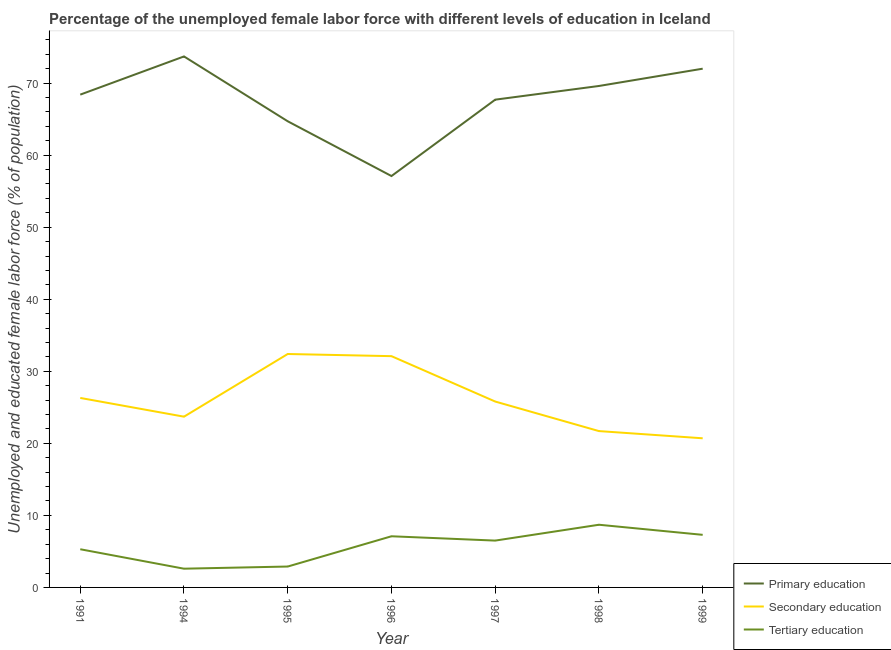How many different coloured lines are there?
Provide a succinct answer. 3. What is the percentage of female labor force who received tertiary education in 1991?
Ensure brevity in your answer.  5.3. Across all years, what is the maximum percentage of female labor force who received tertiary education?
Your response must be concise. 8.7. Across all years, what is the minimum percentage of female labor force who received primary education?
Provide a succinct answer. 57.1. In which year was the percentage of female labor force who received primary education minimum?
Provide a succinct answer. 1996. What is the total percentage of female labor force who received primary education in the graph?
Provide a short and direct response. 473.2. What is the difference between the percentage of female labor force who received tertiary education in 1997 and that in 1999?
Make the answer very short. -0.8. What is the difference between the percentage of female labor force who received tertiary education in 1994 and the percentage of female labor force who received secondary education in 1998?
Provide a short and direct response. -19.1. What is the average percentage of female labor force who received secondary education per year?
Your answer should be very brief. 26.1. In the year 1994, what is the difference between the percentage of female labor force who received tertiary education and percentage of female labor force who received secondary education?
Your answer should be compact. -21.1. In how many years, is the percentage of female labor force who received tertiary education greater than 4 %?
Provide a short and direct response. 5. What is the ratio of the percentage of female labor force who received secondary education in 1997 to that in 1998?
Provide a short and direct response. 1.19. Is the percentage of female labor force who received secondary education in 1996 less than that in 1997?
Provide a succinct answer. No. Is the difference between the percentage of female labor force who received primary education in 1996 and 1997 greater than the difference between the percentage of female labor force who received secondary education in 1996 and 1997?
Make the answer very short. No. What is the difference between the highest and the second highest percentage of female labor force who received tertiary education?
Offer a terse response. 1.4. What is the difference between the highest and the lowest percentage of female labor force who received tertiary education?
Offer a very short reply. 6.1. Is the percentage of female labor force who received secondary education strictly greater than the percentage of female labor force who received primary education over the years?
Provide a short and direct response. No. What is the difference between two consecutive major ticks on the Y-axis?
Your response must be concise. 10. Does the graph contain any zero values?
Provide a short and direct response. No. Does the graph contain grids?
Keep it short and to the point. No. How are the legend labels stacked?
Make the answer very short. Vertical. What is the title of the graph?
Offer a terse response. Percentage of the unemployed female labor force with different levels of education in Iceland. Does "Food" appear as one of the legend labels in the graph?
Your response must be concise. No. What is the label or title of the Y-axis?
Keep it short and to the point. Unemployed and educated female labor force (% of population). What is the Unemployed and educated female labor force (% of population) in Primary education in 1991?
Your answer should be compact. 68.4. What is the Unemployed and educated female labor force (% of population) of Secondary education in 1991?
Your answer should be very brief. 26.3. What is the Unemployed and educated female labor force (% of population) in Tertiary education in 1991?
Your answer should be compact. 5.3. What is the Unemployed and educated female labor force (% of population) in Primary education in 1994?
Your answer should be very brief. 73.7. What is the Unemployed and educated female labor force (% of population) in Secondary education in 1994?
Offer a very short reply. 23.7. What is the Unemployed and educated female labor force (% of population) of Tertiary education in 1994?
Offer a terse response. 2.6. What is the Unemployed and educated female labor force (% of population) of Primary education in 1995?
Your answer should be very brief. 64.7. What is the Unemployed and educated female labor force (% of population) of Secondary education in 1995?
Ensure brevity in your answer.  32.4. What is the Unemployed and educated female labor force (% of population) in Tertiary education in 1995?
Provide a succinct answer. 2.9. What is the Unemployed and educated female labor force (% of population) of Primary education in 1996?
Your answer should be very brief. 57.1. What is the Unemployed and educated female labor force (% of population) in Secondary education in 1996?
Your response must be concise. 32.1. What is the Unemployed and educated female labor force (% of population) of Tertiary education in 1996?
Your answer should be compact. 7.1. What is the Unemployed and educated female labor force (% of population) in Primary education in 1997?
Make the answer very short. 67.7. What is the Unemployed and educated female labor force (% of population) of Secondary education in 1997?
Give a very brief answer. 25.8. What is the Unemployed and educated female labor force (% of population) of Primary education in 1998?
Your answer should be compact. 69.6. What is the Unemployed and educated female labor force (% of population) in Secondary education in 1998?
Give a very brief answer. 21.7. What is the Unemployed and educated female labor force (% of population) in Tertiary education in 1998?
Provide a short and direct response. 8.7. What is the Unemployed and educated female labor force (% of population) of Primary education in 1999?
Your answer should be compact. 72. What is the Unemployed and educated female labor force (% of population) in Secondary education in 1999?
Keep it short and to the point. 20.7. What is the Unemployed and educated female labor force (% of population) in Tertiary education in 1999?
Your response must be concise. 7.3. Across all years, what is the maximum Unemployed and educated female labor force (% of population) in Primary education?
Offer a terse response. 73.7. Across all years, what is the maximum Unemployed and educated female labor force (% of population) of Secondary education?
Give a very brief answer. 32.4. Across all years, what is the maximum Unemployed and educated female labor force (% of population) in Tertiary education?
Provide a short and direct response. 8.7. Across all years, what is the minimum Unemployed and educated female labor force (% of population) in Primary education?
Your answer should be very brief. 57.1. Across all years, what is the minimum Unemployed and educated female labor force (% of population) in Secondary education?
Your answer should be very brief. 20.7. Across all years, what is the minimum Unemployed and educated female labor force (% of population) in Tertiary education?
Provide a succinct answer. 2.6. What is the total Unemployed and educated female labor force (% of population) of Primary education in the graph?
Offer a very short reply. 473.2. What is the total Unemployed and educated female labor force (% of population) of Secondary education in the graph?
Provide a short and direct response. 182.7. What is the total Unemployed and educated female labor force (% of population) of Tertiary education in the graph?
Keep it short and to the point. 40.4. What is the difference between the Unemployed and educated female labor force (% of population) of Secondary education in 1991 and that in 1994?
Provide a succinct answer. 2.6. What is the difference between the Unemployed and educated female labor force (% of population) in Tertiary education in 1991 and that in 1994?
Ensure brevity in your answer.  2.7. What is the difference between the Unemployed and educated female labor force (% of population) in Secondary education in 1991 and that in 1995?
Give a very brief answer. -6.1. What is the difference between the Unemployed and educated female labor force (% of population) in Secondary education in 1991 and that in 1996?
Give a very brief answer. -5.8. What is the difference between the Unemployed and educated female labor force (% of population) of Tertiary education in 1991 and that in 1996?
Offer a terse response. -1.8. What is the difference between the Unemployed and educated female labor force (% of population) of Secondary education in 1991 and that in 1997?
Give a very brief answer. 0.5. What is the difference between the Unemployed and educated female labor force (% of population) of Primary education in 1991 and that in 1998?
Provide a short and direct response. -1.2. What is the difference between the Unemployed and educated female labor force (% of population) in Secondary education in 1991 and that in 1998?
Keep it short and to the point. 4.6. What is the difference between the Unemployed and educated female labor force (% of population) of Primary education in 1991 and that in 1999?
Your answer should be very brief. -3.6. What is the difference between the Unemployed and educated female labor force (% of population) of Secondary education in 1991 and that in 1999?
Your answer should be compact. 5.6. What is the difference between the Unemployed and educated female labor force (% of population) in Primary education in 1994 and that in 1995?
Offer a very short reply. 9. What is the difference between the Unemployed and educated female labor force (% of population) of Tertiary education in 1994 and that in 1995?
Provide a succinct answer. -0.3. What is the difference between the Unemployed and educated female labor force (% of population) of Primary education in 1994 and that in 1997?
Provide a short and direct response. 6. What is the difference between the Unemployed and educated female labor force (% of population) in Secondary education in 1994 and that in 1997?
Your answer should be compact. -2.1. What is the difference between the Unemployed and educated female labor force (% of population) of Tertiary education in 1994 and that in 1997?
Your response must be concise. -3.9. What is the difference between the Unemployed and educated female labor force (% of population) of Tertiary education in 1994 and that in 1998?
Offer a very short reply. -6.1. What is the difference between the Unemployed and educated female labor force (% of population) of Secondary education in 1994 and that in 1999?
Provide a succinct answer. 3. What is the difference between the Unemployed and educated female labor force (% of population) in Tertiary education in 1994 and that in 1999?
Provide a short and direct response. -4.7. What is the difference between the Unemployed and educated female labor force (% of population) of Primary education in 1995 and that in 1996?
Make the answer very short. 7.6. What is the difference between the Unemployed and educated female labor force (% of population) of Secondary education in 1995 and that in 1996?
Your answer should be compact. 0.3. What is the difference between the Unemployed and educated female labor force (% of population) of Primary education in 1995 and that in 1997?
Your response must be concise. -3. What is the difference between the Unemployed and educated female labor force (% of population) in Secondary education in 1995 and that in 1997?
Ensure brevity in your answer.  6.6. What is the difference between the Unemployed and educated female labor force (% of population) of Tertiary education in 1995 and that in 1997?
Ensure brevity in your answer.  -3.6. What is the difference between the Unemployed and educated female labor force (% of population) of Tertiary education in 1995 and that in 1998?
Give a very brief answer. -5.8. What is the difference between the Unemployed and educated female labor force (% of population) of Primary education in 1995 and that in 1999?
Offer a very short reply. -7.3. What is the difference between the Unemployed and educated female labor force (% of population) of Tertiary education in 1996 and that in 1998?
Ensure brevity in your answer.  -1.6. What is the difference between the Unemployed and educated female labor force (% of population) in Primary education in 1996 and that in 1999?
Provide a succinct answer. -14.9. What is the difference between the Unemployed and educated female labor force (% of population) in Secondary education in 1996 and that in 1999?
Provide a succinct answer. 11.4. What is the difference between the Unemployed and educated female labor force (% of population) in Tertiary education in 1996 and that in 1999?
Make the answer very short. -0.2. What is the difference between the Unemployed and educated female labor force (% of population) in Tertiary education in 1997 and that in 1999?
Make the answer very short. -0.8. What is the difference between the Unemployed and educated female labor force (% of population) in Primary education in 1998 and that in 1999?
Make the answer very short. -2.4. What is the difference between the Unemployed and educated female labor force (% of population) in Tertiary education in 1998 and that in 1999?
Provide a short and direct response. 1.4. What is the difference between the Unemployed and educated female labor force (% of population) of Primary education in 1991 and the Unemployed and educated female labor force (% of population) of Secondary education in 1994?
Your response must be concise. 44.7. What is the difference between the Unemployed and educated female labor force (% of population) of Primary education in 1991 and the Unemployed and educated female labor force (% of population) of Tertiary education in 1994?
Make the answer very short. 65.8. What is the difference between the Unemployed and educated female labor force (% of population) of Secondary education in 1991 and the Unemployed and educated female labor force (% of population) of Tertiary education in 1994?
Keep it short and to the point. 23.7. What is the difference between the Unemployed and educated female labor force (% of population) of Primary education in 1991 and the Unemployed and educated female labor force (% of population) of Secondary education in 1995?
Offer a very short reply. 36. What is the difference between the Unemployed and educated female labor force (% of population) of Primary education in 1991 and the Unemployed and educated female labor force (% of population) of Tertiary education in 1995?
Keep it short and to the point. 65.5. What is the difference between the Unemployed and educated female labor force (% of population) in Secondary education in 1991 and the Unemployed and educated female labor force (% of population) in Tertiary education in 1995?
Your answer should be compact. 23.4. What is the difference between the Unemployed and educated female labor force (% of population) of Primary education in 1991 and the Unemployed and educated female labor force (% of population) of Secondary education in 1996?
Make the answer very short. 36.3. What is the difference between the Unemployed and educated female labor force (% of population) of Primary education in 1991 and the Unemployed and educated female labor force (% of population) of Tertiary education in 1996?
Your answer should be compact. 61.3. What is the difference between the Unemployed and educated female labor force (% of population) in Secondary education in 1991 and the Unemployed and educated female labor force (% of population) in Tertiary education in 1996?
Your response must be concise. 19.2. What is the difference between the Unemployed and educated female labor force (% of population) in Primary education in 1991 and the Unemployed and educated female labor force (% of population) in Secondary education in 1997?
Provide a short and direct response. 42.6. What is the difference between the Unemployed and educated female labor force (% of population) of Primary education in 1991 and the Unemployed and educated female labor force (% of population) of Tertiary education in 1997?
Offer a very short reply. 61.9. What is the difference between the Unemployed and educated female labor force (% of population) of Secondary education in 1991 and the Unemployed and educated female labor force (% of population) of Tertiary education in 1997?
Offer a very short reply. 19.8. What is the difference between the Unemployed and educated female labor force (% of population) in Primary education in 1991 and the Unemployed and educated female labor force (% of population) in Secondary education in 1998?
Your response must be concise. 46.7. What is the difference between the Unemployed and educated female labor force (% of population) in Primary education in 1991 and the Unemployed and educated female labor force (% of population) in Tertiary education in 1998?
Provide a short and direct response. 59.7. What is the difference between the Unemployed and educated female labor force (% of population) in Secondary education in 1991 and the Unemployed and educated female labor force (% of population) in Tertiary education in 1998?
Offer a terse response. 17.6. What is the difference between the Unemployed and educated female labor force (% of population) in Primary education in 1991 and the Unemployed and educated female labor force (% of population) in Secondary education in 1999?
Your answer should be very brief. 47.7. What is the difference between the Unemployed and educated female labor force (% of population) of Primary education in 1991 and the Unemployed and educated female labor force (% of population) of Tertiary education in 1999?
Your response must be concise. 61.1. What is the difference between the Unemployed and educated female labor force (% of population) of Secondary education in 1991 and the Unemployed and educated female labor force (% of population) of Tertiary education in 1999?
Ensure brevity in your answer.  19. What is the difference between the Unemployed and educated female labor force (% of population) in Primary education in 1994 and the Unemployed and educated female labor force (% of population) in Secondary education in 1995?
Make the answer very short. 41.3. What is the difference between the Unemployed and educated female labor force (% of population) in Primary education in 1994 and the Unemployed and educated female labor force (% of population) in Tertiary education in 1995?
Offer a terse response. 70.8. What is the difference between the Unemployed and educated female labor force (% of population) in Secondary education in 1994 and the Unemployed and educated female labor force (% of population) in Tertiary education in 1995?
Keep it short and to the point. 20.8. What is the difference between the Unemployed and educated female labor force (% of population) in Primary education in 1994 and the Unemployed and educated female labor force (% of population) in Secondary education in 1996?
Provide a short and direct response. 41.6. What is the difference between the Unemployed and educated female labor force (% of population) of Primary education in 1994 and the Unemployed and educated female labor force (% of population) of Tertiary education in 1996?
Offer a terse response. 66.6. What is the difference between the Unemployed and educated female labor force (% of population) in Secondary education in 1994 and the Unemployed and educated female labor force (% of population) in Tertiary education in 1996?
Your answer should be very brief. 16.6. What is the difference between the Unemployed and educated female labor force (% of population) in Primary education in 1994 and the Unemployed and educated female labor force (% of population) in Secondary education in 1997?
Provide a short and direct response. 47.9. What is the difference between the Unemployed and educated female labor force (% of population) of Primary education in 1994 and the Unemployed and educated female labor force (% of population) of Tertiary education in 1997?
Your answer should be compact. 67.2. What is the difference between the Unemployed and educated female labor force (% of population) of Primary education in 1994 and the Unemployed and educated female labor force (% of population) of Tertiary education in 1998?
Offer a terse response. 65. What is the difference between the Unemployed and educated female labor force (% of population) of Primary education in 1994 and the Unemployed and educated female labor force (% of population) of Secondary education in 1999?
Your answer should be very brief. 53. What is the difference between the Unemployed and educated female labor force (% of population) of Primary education in 1994 and the Unemployed and educated female labor force (% of population) of Tertiary education in 1999?
Offer a very short reply. 66.4. What is the difference between the Unemployed and educated female labor force (% of population) in Primary education in 1995 and the Unemployed and educated female labor force (% of population) in Secondary education in 1996?
Make the answer very short. 32.6. What is the difference between the Unemployed and educated female labor force (% of population) of Primary education in 1995 and the Unemployed and educated female labor force (% of population) of Tertiary education in 1996?
Offer a terse response. 57.6. What is the difference between the Unemployed and educated female labor force (% of population) in Secondary education in 1995 and the Unemployed and educated female labor force (% of population) in Tertiary education in 1996?
Your answer should be very brief. 25.3. What is the difference between the Unemployed and educated female labor force (% of population) in Primary education in 1995 and the Unemployed and educated female labor force (% of population) in Secondary education in 1997?
Keep it short and to the point. 38.9. What is the difference between the Unemployed and educated female labor force (% of population) of Primary education in 1995 and the Unemployed and educated female labor force (% of population) of Tertiary education in 1997?
Offer a very short reply. 58.2. What is the difference between the Unemployed and educated female labor force (% of population) in Secondary education in 1995 and the Unemployed and educated female labor force (% of population) in Tertiary education in 1997?
Offer a very short reply. 25.9. What is the difference between the Unemployed and educated female labor force (% of population) in Primary education in 1995 and the Unemployed and educated female labor force (% of population) in Tertiary education in 1998?
Your response must be concise. 56. What is the difference between the Unemployed and educated female labor force (% of population) in Secondary education in 1995 and the Unemployed and educated female labor force (% of population) in Tertiary education in 1998?
Your response must be concise. 23.7. What is the difference between the Unemployed and educated female labor force (% of population) of Primary education in 1995 and the Unemployed and educated female labor force (% of population) of Tertiary education in 1999?
Your answer should be very brief. 57.4. What is the difference between the Unemployed and educated female labor force (% of population) of Secondary education in 1995 and the Unemployed and educated female labor force (% of population) of Tertiary education in 1999?
Ensure brevity in your answer.  25.1. What is the difference between the Unemployed and educated female labor force (% of population) in Primary education in 1996 and the Unemployed and educated female labor force (% of population) in Secondary education in 1997?
Your answer should be very brief. 31.3. What is the difference between the Unemployed and educated female labor force (% of population) in Primary education in 1996 and the Unemployed and educated female labor force (% of population) in Tertiary education in 1997?
Give a very brief answer. 50.6. What is the difference between the Unemployed and educated female labor force (% of population) of Secondary education in 1996 and the Unemployed and educated female labor force (% of population) of Tertiary education in 1997?
Your response must be concise. 25.6. What is the difference between the Unemployed and educated female labor force (% of population) in Primary education in 1996 and the Unemployed and educated female labor force (% of population) in Secondary education in 1998?
Your answer should be very brief. 35.4. What is the difference between the Unemployed and educated female labor force (% of population) in Primary education in 1996 and the Unemployed and educated female labor force (% of population) in Tertiary education in 1998?
Provide a short and direct response. 48.4. What is the difference between the Unemployed and educated female labor force (% of population) in Secondary education in 1996 and the Unemployed and educated female labor force (% of population) in Tertiary education in 1998?
Provide a short and direct response. 23.4. What is the difference between the Unemployed and educated female labor force (% of population) of Primary education in 1996 and the Unemployed and educated female labor force (% of population) of Secondary education in 1999?
Give a very brief answer. 36.4. What is the difference between the Unemployed and educated female labor force (% of population) of Primary education in 1996 and the Unemployed and educated female labor force (% of population) of Tertiary education in 1999?
Your answer should be compact. 49.8. What is the difference between the Unemployed and educated female labor force (% of population) in Secondary education in 1996 and the Unemployed and educated female labor force (% of population) in Tertiary education in 1999?
Your response must be concise. 24.8. What is the difference between the Unemployed and educated female labor force (% of population) in Primary education in 1997 and the Unemployed and educated female labor force (% of population) in Secondary education in 1998?
Give a very brief answer. 46. What is the difference between the Unemployed and educated female labor force (% of population) of Primary education in 1997 and the Unemployed and educated female labor force (% of population) of Tertiary education in 1998?
Your answer should be very brief. 59. What is the difference between the Unemployed and educated female labor force (% of population) in Secondary education in 1997 and the Unemployed and educated female labor force (% of population) in Tertiary education in 1998?
Your response must be concise. 17.1. What is the difference between the Unemployed and educated female labor force (% of population) of Primary education in 1997 and the Unemployed and educated female labor force (% of population) of Tertiary education in 1999?
Provide a short and direct response. 60.4. What is the difference between the Unemployed and educated female labor force (% of population) in Secondary education in 1997 and the Unemployed and educated female labor force (% of population) in Tertiary education in 1999?
Ensure brevity in your answer.  18.5. What is the difference between the Unemployed and educated female labor force (% of population) in Primary education in 1998 and the Unemployed and educated female labor force (% of population) in Secondary education in 1999?
Your answer should be compact. 48.9. What is the difference between the Unemployed and educated female labor force (% of population) in Primary education in 1998 and the Unemployed and educated female labor force (% of population) in Tertiary education in 1999?
Provide a succinct answer. 62.3. What is the difference between the Unemployed and educated female labor force (% of population) of Secondary education in 1998 and the Unemployed and educated female labor force (% of population) of Tertiary education in 1999?
Give a very brief answer. 14.4. What is the average Unemployed and educated female labor force (% of population) in Primary education per year?
Offer a very short reply. 67.6. What is the average Unemployed and educated female labor force (% of population) of Secondary education per year?
Your response must be concise. 26.1. What is the average Unemployed and educated female labor force (% of population) in Tertiary education per year?
Offer a very short reply. 5.77. In the year 1991, what is the difference between the Unemployed and educated female labor force (% of population) of Primary education and Unemployed and educated female labor force (% of population) of Secondary education?
Your answer should be very brief. 42.1. In the year 1991, what is the difference between the Unemployed and educated female labor force (% of population) in Primary education and Unemployed and educated female labor force (% of population) in Tertiary education?
Keep it short and to the point. 63.1. In the year 1991, what is the difference between the Unemployed and educated female labor force (% of population) in Secondary education and Unemployed and educated female labor force (% of population) in Tertiary education?
Keep it short and to the point. 21. In the year 1994, what is the difference between the Unemployed and educated female labor force (% of population) of Primary education and Unemployed and educated female labor force (% of population) of Secondary education?
Your response must be concise. 50. In the year 1994, what is the difference between the Unemployed and educated female labor force (% of population) of Primary education and Unemployed and educated female labor force (% of population) of Tertiary education?
Provide a short and direct response. 71.1. In the year 1994, what is the difference between the Unemployed and educated female labor force (% of population) in Secondary education and Unemployed and educated female labor force (% of population) in Tertiary education?
Your response must be concise. 21.1. In the year 1995, what is the difference between the Unemployed and educated female labor force (% of population) of Primary education and Unemployed and educated female labor force (% of population) of Secondary education?
Your answer should be compact. 32.3. In the year 1995, what is the difference between the Unemployed and educated female labor force (% of population) of Primary education and Unemployed and educated female labor force (% of population) of Tertiary education?
Your response must be concise. 61.8. In the year 1995, what is the difference between the Unemployed and educated female labor force (% of population) of Secondary education and Unemployed and educated female labor force (% of population) of Tertiary education?
Your answer should be very brief. 29.5. In the year 1996, what is the difference between the Unemployed and educated female labor force (% of population) of Primary education and Unemployed and educated female labor force (% of population) of Secondary education?
Your response must be concise. 25. In the year 1997, what is the difference between the Unemployed and educated female labor force (% of population) in Primary education and Unemployed and educated female labor force (% of population) in Secondary education?
Make the answer very short. 41.9. In the year 1997, what is the difference between the Unemployed and educated female labor force (% of population) in Primary education and Unemployed and educated female labor force (% of population) in Tertiary education?
Keep it short and to the point. 61.2. In the year 1997, what is the difference between the Unemployed and educated female labor force (% of population) in Secondary education and Unemployed and educated female labor force (% of population) in Tertiary education?
Ensure brevity in your answer.  19.3. In the year 1998, what is the difference between the Unemployed and educated female labor force (% of population) of Primary education and Unemployed and educated female labor force (% of population) of Secondary education?
Offer a very short reply. 47.9. In the year 1998, what is the difference between the Unemployed and educated female labor force (% of population) in Primary education and Unemployed and educated female labor force (% of population) in Tertiary education?
Your answer should be compact. 60.9. In the year 1999, what is the difference between the Unemployed and educated female labor force (% of population) in Primary education and Unemployed and educated female labor force (% of population) in Secondary education?
Offer a terse response. 51.3. In the year 1999, what is the difference between the Unemployed and educated female labor force (% of population) of Primary education and Unemployed and educated female labor force (% of population) of Tertiary education?
Your answer should be compact. 64.7. In the year 1999, what is the difference between the Unemployed and educated female labor force (% of population) of Secondary education and Unemployed and educated female labor force (% of population) of Tertiary education?
Provide a short and direct response. 13.4. What is the ratio of the Unemployed and educated female labor force (% of population) of Primary education in 1991 to that in 1994?
Offer a very short reply. 0.93. What is the ratio of the Unemployed and educated female labor force (% of population) of Secondary education in 1991 to that in 1994?
Ensure brevity in your answer.  1.11. What is the ratio of the Unemployed and educated female labor force (% of population) of Tertiary education in 1991 to that in 1994?
Your answer should be compact. 2.04. What is the ratio of the Unemployed and educated female labor force (% of population) in Primary education in 1991 to that in 1995?
Provide a short and direct response. 1.06. What is the ratio of the Unemployed and educated female labor force (% of population) of Secondary education in 1991 to that in 1995?
Provide a short and direct response. 0.81. What is the ratio of the Unemployed and educated female labor force (% of population) in Tertiary education in 1991 to that in 1995?
Your response must be concise. 1.83. What is the ratio of the Unemployed and educated female labor force (% of population) in Primary education in 1991 to that in 1996?
Offer a terse response. 1.2. What is the ratio of the Unemployed and educated female labor force (% of population) of Secondary education in 1991 to that in 1996?
Your response must be concise. 0.82. What is the ratio of the Unemployed and educated female labor force (% of population) of Tertiary education in 1991 to that in 1996?
Your answer should be compact. 0.75. What is the ratio of the Unemployed and educated female labor force (% of population) in Primary education in 1991 to that in 1997?
Ensure brevity in your answer.  1.01. What is the ratio of the Unemployed and educated female labor force (% of population) in Secondary education in 1991 to that in 1997?
Keep it short and to the point. 1.02. What is the ratio of the Unemployed and educated female labor force (% of population) in Tertiary education in 1991 to that in 1997?
Make the answer very short. 0.82. What is the ratio of the Unemployed and educated female labor force (% of population) of Primary education in 1991 to that in 1998?
Keep it short and to the point. 0.98. What is the ratio of the Unemployed and educated female labor force (% of population) of Secondary education in 1991 to that in 1998?
Make the answer very short. 1.21. What is the ratio of the Unemployed and educated female labor force (% of population) in Tertiary education in 1991 to that in 1998?
Give a very brief answer. 0.61. What is the ratio of the Unemployed and educated female labor force (% of population) in Primary education in 1991 to that in 1999?
Make the answer very short. 0.95. What is the ratio of the Unemployed and educated female labor force (% of population) in Secondary education in 1991 to that in 1999?
Provide a short and direct response. 1.27. What is the ratio of the Unemployed and educated female labor force (% of population) in Tertiary education in 1991 to that in 1999?
Keep it short and to the point. 0.73. What is the ratio of the Unemployed and educated female labor force (% of population) in Primary education in 1994 to that in 1995?
Provide a succinct answer. 1.14. What is the ratio of the Unemployed and educated female labor force (% of population) in Secondary education in 1994 to that in 1995?
Your answer should be compact. 0.73. What is the ratio of the Unemployed and educated female labor force (% of population) in Tertiary education in 1994 to that in 1995?
Offer a terse response. 0.9. What is the ratio of the Unemployed and educated female labor force (% of population) of Primary education in 1994 to that in 1996?
Your answer should be compact. 1.29. What is the ratio of the Unemployed and educated female labor force (% of population) of Secondary education in 1994 to that in 1996?
Your response must be concise. 0.74. What is the ratio of the Unemployed and educated female labor force (% of population) in Tertiary education in 1994 to that in 1996?
Your answer should be very brief. 0.37. What is the ratio of the Unemployed and educated female labor force (% of population) of Primary education in 1994 to that in 1997?
Give a very brief answer. 1.09. What is the ratio of the Unemployed and educated female labor force (% of population) in Secondary education in 1994 to that in 1997?
Your answer should be very brief. 0.92. What is the ratio of the Unemployed and educated female labor force (% of population) of Primary education in 1994 to that in 1998?
Ensure brevity in your answer.  1.06. What is the ratio of the Unemployed and educated female labor force (% of population) in Secondary education in 1994 to that in 1998?
Your response must be concise. 1.09. What is the ratio of the Unemployed and educated female labor force (% of population) in Tertiary education in 1994 to that in 1998?
Provide a short and direct response. 0.3. What is the ratio of the Unemployed and educated female labor force (% of population) of Primary education in 1994 to that in 1999?
Your response must be concise. 1.02. What is the ratio of the Unemployed and educated female labor force (% of population) of Secondary education in 1994 to that in 1999?
Keep it short and to the point. 1.14. What is the ratio of the Unemployed and educated female labor force (% of population) in Tertiary education in 1994 to that in 1999?
Offer a terse response. 0.36. What is the ratio of the Unemployed and educated female labor force (% of population) in Primary education in 1995 to that in 1996?
Ensure brevity in your answer.  1.13. What is the ratio of the Unemployed and educated female labor force (% of population) of Secondary education in 1995 to that in 1996?
Offer a very short reply. 1.01. What is the ratio of the Unemployed and educated female labor force (% of population) of Tertiary education in 1995 to that in 1996?
Offer a terse response. 0.41. What is the ratio of the Unemployed and educated female labor force (% of population) of Primary education in 1995 to that in 1997?
Make the answer very short. 0.96. What is the ratio of the Unemployed and educated female labor force (% of population) in Secondary education in 1995 to that in 1997?
Give a very brief answer. 1.26. What is the ratio of the Unemployed and educated female labor force (% of population) in Tertiary education in 1995 to that in 1997?
Provide a short and direct response. 0.45. What is the ratio of the Unemployed and educated female labor force (% of population) in Primary education in 1995 to that in 1998?
Provide a short and direct response. 0.93. What is the ratio of the Unemployed and educated female labor force (% of population) of Secondary education in 1995 to that in 1998?
Give a very brief answer. 1.49. What is the ratio of the Unemployed and educated female labor force (% of population) in Tertiary education in 1995 to that in 1998?
Ensure brevity in your answer.  0.33. What is the ratio of the Unemployed and educated female labor force (% of population) in Primary education in 1995 to that in 1999?
Your response must be concise. 0.9. What is the ratio of the Unemployed and educated female labor force (% of population) of Secondary education in 1995 to that in 1999?
Offer a terse response. 1.57. What is the ratio of the Unemployed and educated female labor force (% of population) in Tertiary education in 1995 to that in 1999?
Provide a succinct answer. 0.4. What is the ratio of the Unemployed and educated female labor force (% of population) in Primary education in 1996 to that in 1997?
Ensure brevity in your answer.  0.84. What is the ratio of the Unemployed and educated female labor force (% of population) in Secondary education in 1996 to that in 1997?
Your answer should be compact. 1.24. What is the ratio of the Unemployed and educated female labor force (% of population) of Tertiary education in 1996 to that in 1997?
Give a very brief answer. 1.09. What is the ratio of the Unemployed and educated female labor force (% of population) of Primary education in 1996 to that in 1998?
Your response must be concise. 0.82. What is the ratio of the Unemployed and educated female labor force (% of population) of Secondary education in 1996 to that in 1998?
Make the answer very short. 1.48. What is the ratio of the Unemployed and educated female labor force (% of population) of Tertiary education in 1996 to that in 1998?
Your response must be concise. 0.82. What is the ratio of the Unemployed and educated female labor force (% of population) of Primary education in 1996 to that in 1999?
Ensure brevity in your answer.  0.79. What is the ratio of the Unemployed and educated female labor force (% of population) in Secondary education in 1996 to that in 1999?
Offer a very short reply. 1.55. What is the ratio of the Unemployed and educated female labor force (% of population) of Tertiary education in 1996 to that in 1999?
Your answer should be very brief. 0.97. What is the ratio of the Unemployed and educated female labor force (% of population) in Primary education in 1997 to that in 1998?
Your answer should be very brief. 0.97. What is the ratio of the Unemployed and educated female labor force (% of population) of Secondary education in 1997 to that in 1998?
Give a very brief answer. 1.19. What is the ratio of the Unemployed and educated female labor force (% of population) in Tertiary education in 1997 to that in 1998?
Your answer should be compact. 0.75. What is the ratio of the Unemployed and educated female labor force (% of population) of Primary education in 1997 to that in 1999?
Keep it short and to the point. 0.94. What is the ratio of the Unemployed and educated female labor force (% of population) in Secondary education in 1997 to that in 1999?
Ensure brevity in your answer.  1.25. What is the ratio of the Unemployed and educated female labor force (% of population) of Tertiary education in 1997 to that in 1999?
Offer a terse response. 0.89. What is the ratio of the Unemployed and educated female labor force (% of population) of Primary education in 1998 to that in 1999?
Offer a terse response. 0.97. What is the ratio of the Unemployed and educated female labor force (% of population) in Secondary education in 1998 to that in 1999?
Keep it short and to the point. 1.05. What is the ratio of the Unemployed and educated female labor force (% of population) of Tertiary education in 1998 to that in 1999?
Provide a short and direct response. 1.19. What is the difference between the highest and the second highest Unemployed and educated female labor force (% of population) in Secondary education?
Make the answer very short. 0.3. What is the difference between the highest and the lowest Unemployed and educated female labor force (% of population) in Secondary education?
Offer a very short reply. 11.7. What is the difference between the highest and the lowest Unemployed and educated female labor force (% of population) of Tertiary education?
Provide a succinct answer. 6.1. 